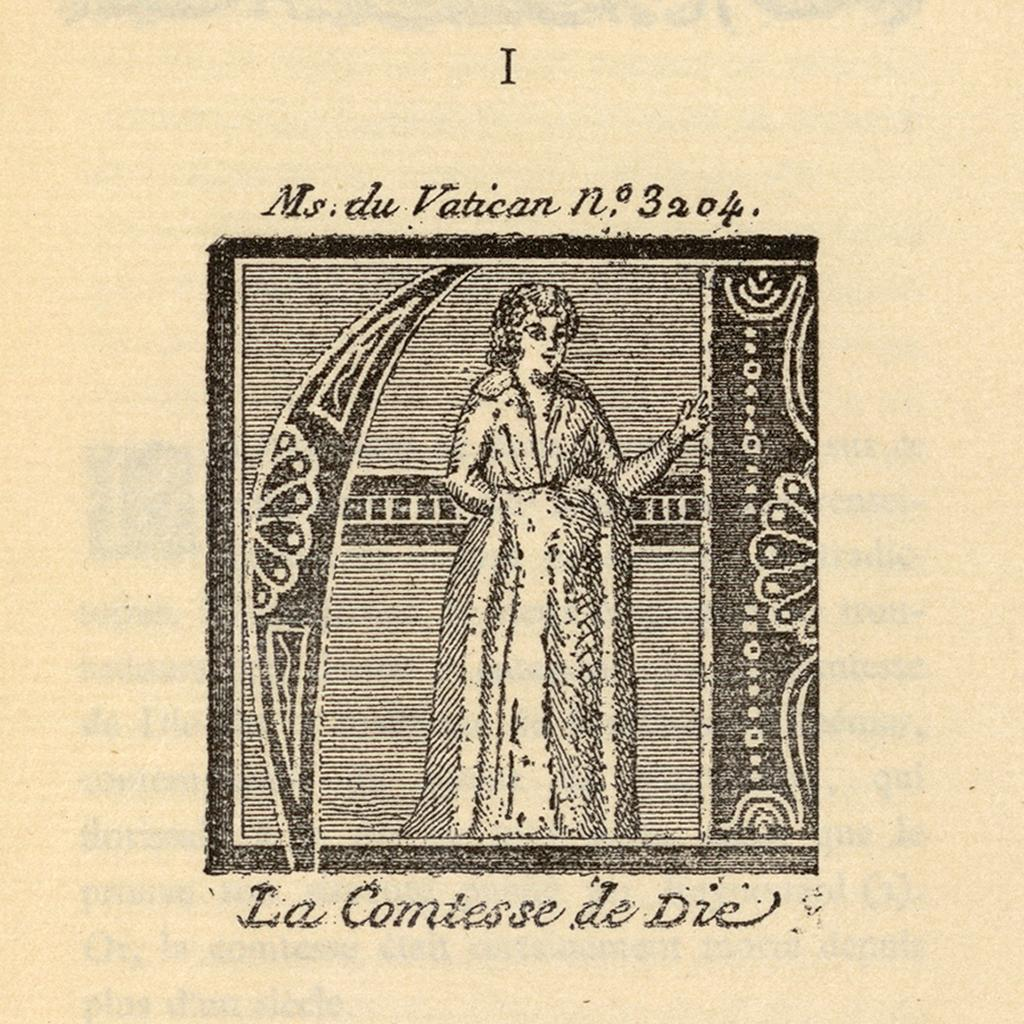What is present on the paper in the image? There is an image of a woman on the paper. What else can be seen on the paper besides the image? There is text on the paper. How many yaks are visible in the image? There are no yaks present in the image. What type of roll is being used to hold the paper in the image? There is no roll present in the image; the paper is not being held by any roll. 